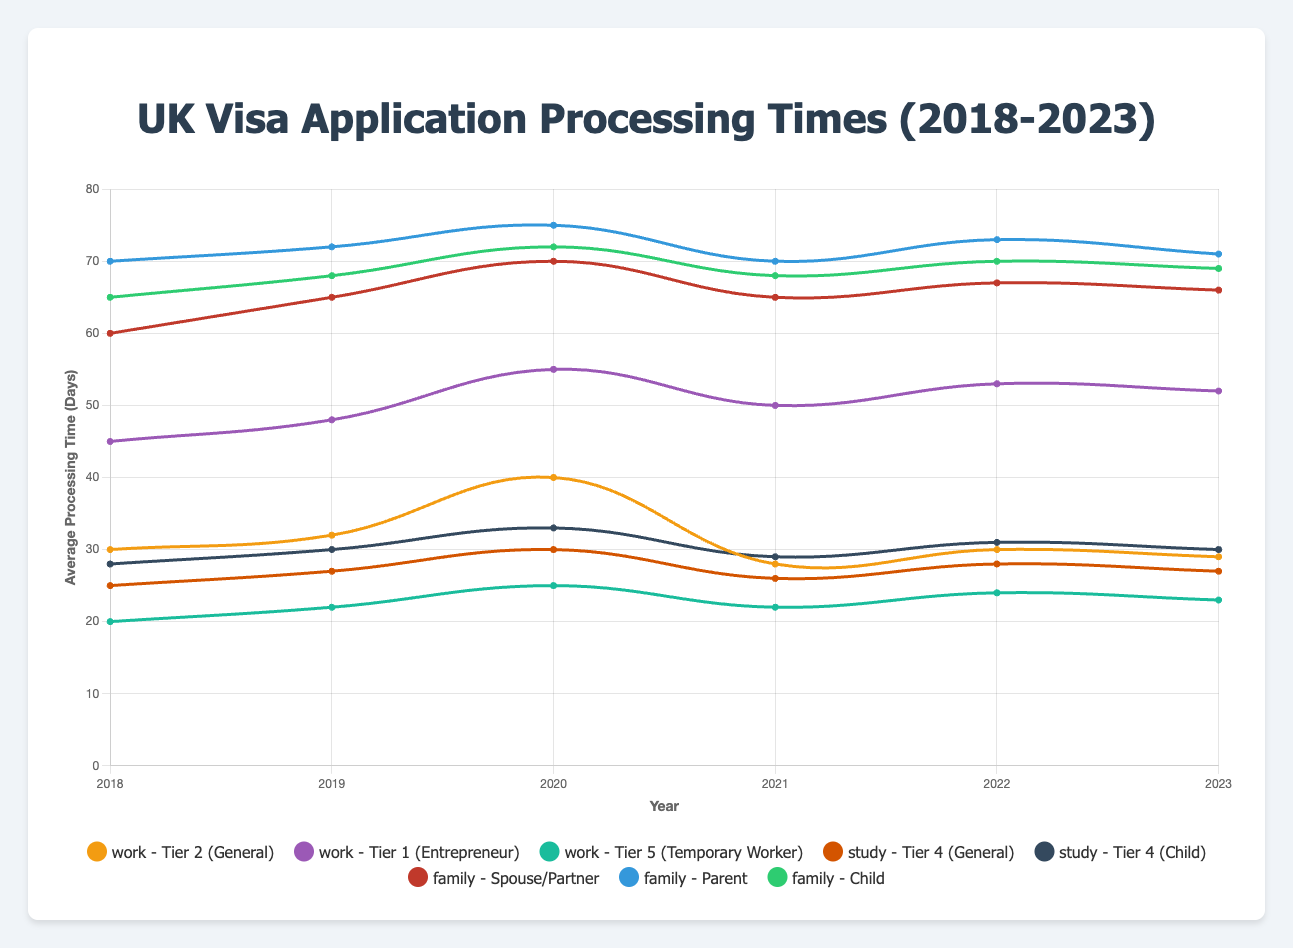What is the average processing time for Tier 2 (General) work visas in 2022? The average processing time for Tier 2 (General) work visas in 2022 can be directly seen in the figure. For the year 2022, it is 30 days.
Answer: 30 days Which visa type had the highest average processing time in 2021, and what was that time? To determine the highest average processing time in 2021, we need to compare the processing times for all visa types in that year. The highest is for Parent visas in the family category, with an average processing time of 70 days.
Answer: Parent visa, 70 days By how many days did the average processing time for Tier 4 (General) study visas increase from 2018 to 2020? The average processing time for Tier 4 (General) study visas was 25 days in 2018 and 30 days in 2020. The increase is 30 - 25 = 5 days.
Answer: 5 days What is the trend of the average processing time for Spouse/Partner family visas from 2018 to 2023? Observing the data points from 2018 to 2023 for Spouse/Partner family visas: 60, 65, 70, 65, 67, 66 days, there is a general increasing trend from 2018 to 2020, then a slight decrease and stabilization from 2021 to 2023.
Answer: Increasing then stabilizing Compare the average processing times for Tier 1 (Entrepreneur) work visas and Tier 4 (Child) study visas in 2022. Which one is higher and by how much? In 2022, the average processing time for Tier 1 (Entrepreneur) work visas is 53 days, while for Tier 4 (Child) study visas it is 31 days. The Tier 1 (Entrepreneur) work visa processing time is 53 - 31 = 22 days higher.
Answer: Tier 1 (Entrepreneur) by 22 days Which visa category (work, study, or family) consistently had the highest average processing times from 2018 to 2023? Observing the highest averages within the work, study, and family categories over the years: the family category consistently has higher average processing times compared to work and study visas.
Answer: Family What was the lowest average processing time among all visa types in 2019, and for which visa was this time recorded? In 2019, the lowest average processing time was for Tier 5 (Temporary Worker) work visas, recorded at 22 days.
Answer: Tier 5 (Temporary Worker), 22 days Calculate the average processing time across all years for Tier 4 (General) study visas. Adding the average processing times from 2018 to 2023: (25 + 27 + 30 + 26 + 28 + 27) = 163 days. Dividing by 6 years gives an average of 163 / 6 ≈ 27.17 days.
Answer: 27.17 days Which visa type experienced the most significant fluctuation in average processing times over the years? The Tier 2 (General) work visa shows significant fluctuations in average processing times, ranging from 28 days in 2021 to 40 days in 2020. The fluctuation is analyzed based on the variation of values compared to other visa types.
Answer: Tier 2 (General) 